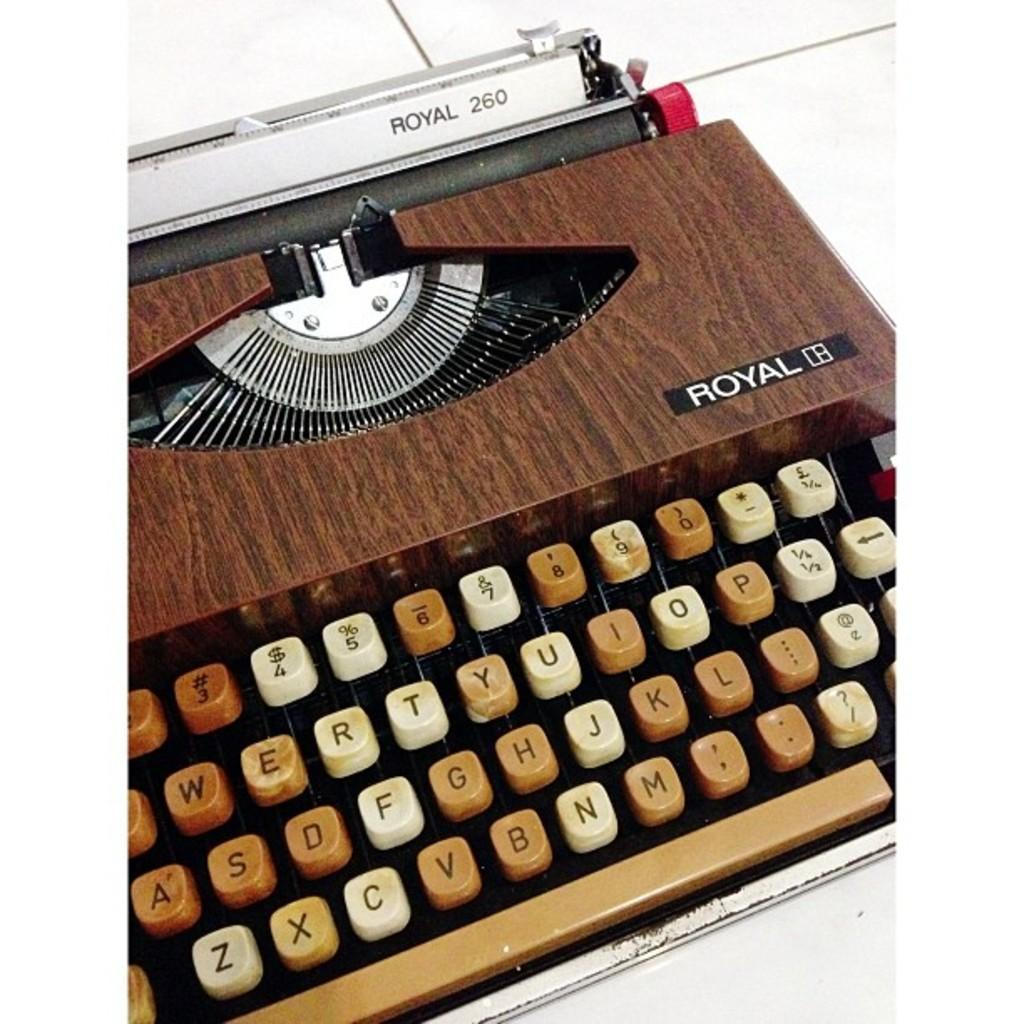<image>
Render a clear and concise summary of the photo. A Vintage wood grain Royal 260 model typewriter. 